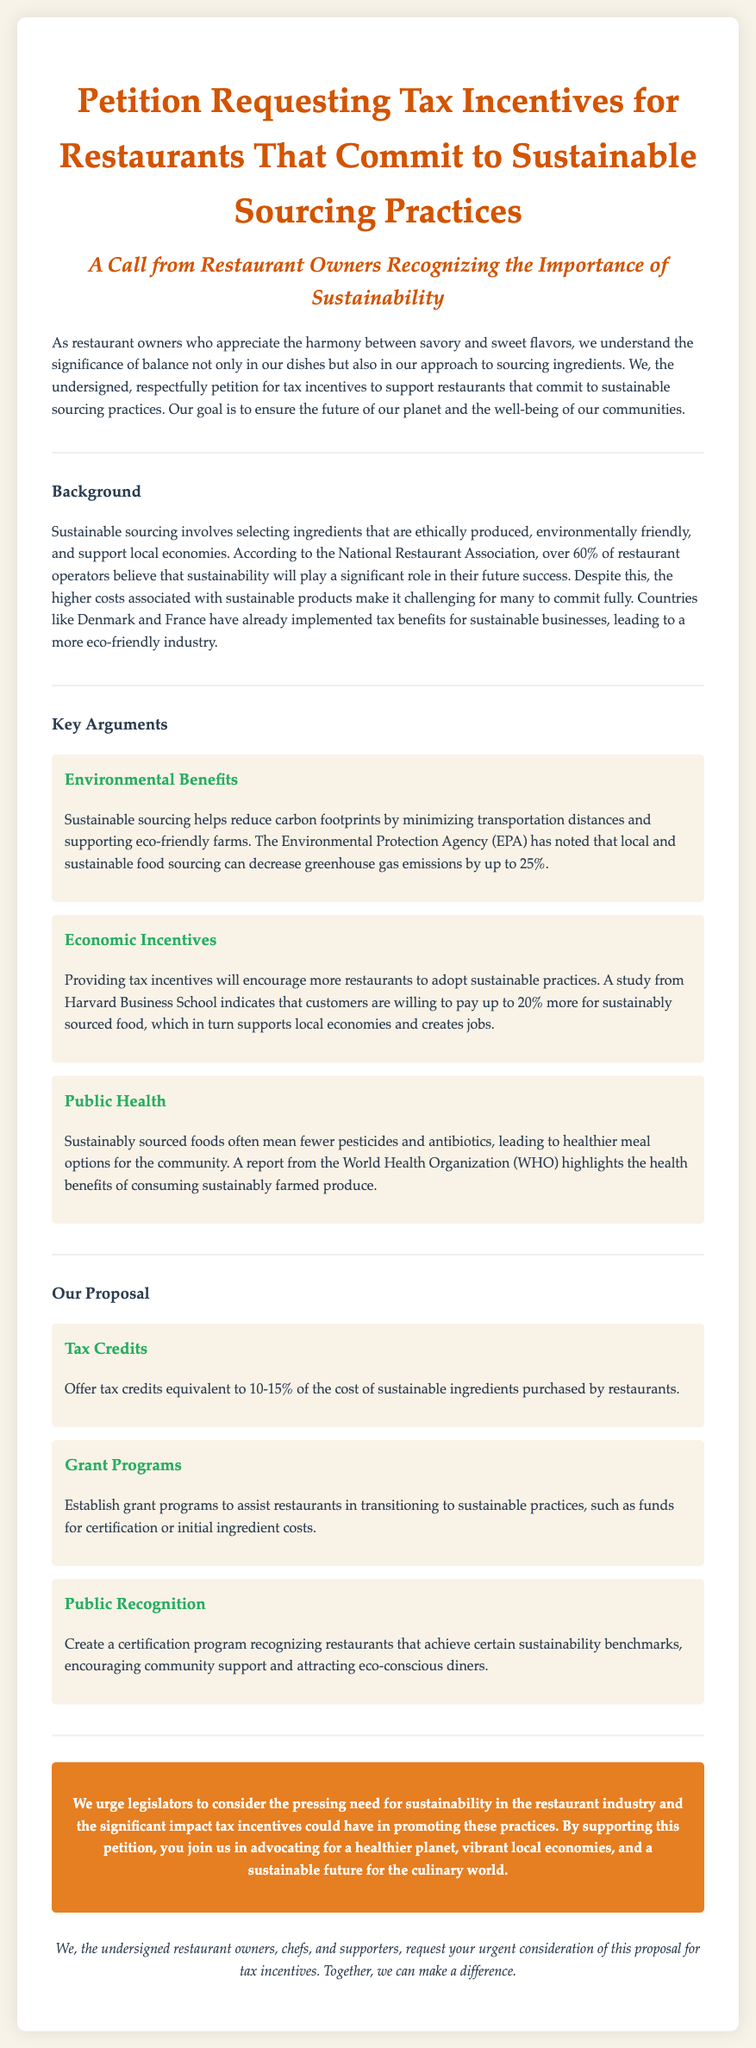What is the main title of the petition? The main title clearly states the purpose of the document regarding tax incentives for sustainable sourcing practices.
Answer: Petition Requesting Tax Incentives for Restaurants That Commit to Sustainable Sourcing Practices Who is addressing the petition? The petition is addressed by restaurant owners who recognize the importance of sustainability.
Answer: Restaurant Owners What percentage of restaurant operators believe sustainability is important for future success? This information indicates the awareness and attitudes of the restaurant community towards sustainability.
Answer: Over 60% What environmental benefit is mentioned regarding sustainable sourcing? This highlights the positive impact that sustainable sourcing has on the environment, particularly in emissions.
Answer: Reduce carbon footprints How much tax credit is proposed for sustainable ingredients? This reveals the financial incentive suggested in the petition to promote sustainable sourcing.
Answer: 10-15% What type of programs does the petition suggest to help restaurants transition to sustainable practices? This focuses on the assistance that could be provided to restaurants making sustainable changes.
Answer: Grant Programs What organization noted the health benefits of sustainably sourced foods? This identifies credible sources that support the claims made in the petition about public health.
Answer: World Health Organization What is a proposed certification program aimed to do? This explores the intended outcome of recognition for restaurants achieving sustainability.
Answer: Encourage community support What does the petition urge legislators to consider? This captures the primary action the petition seeks from lawmakers regarding sustainability.
Answer: Tax incentives 